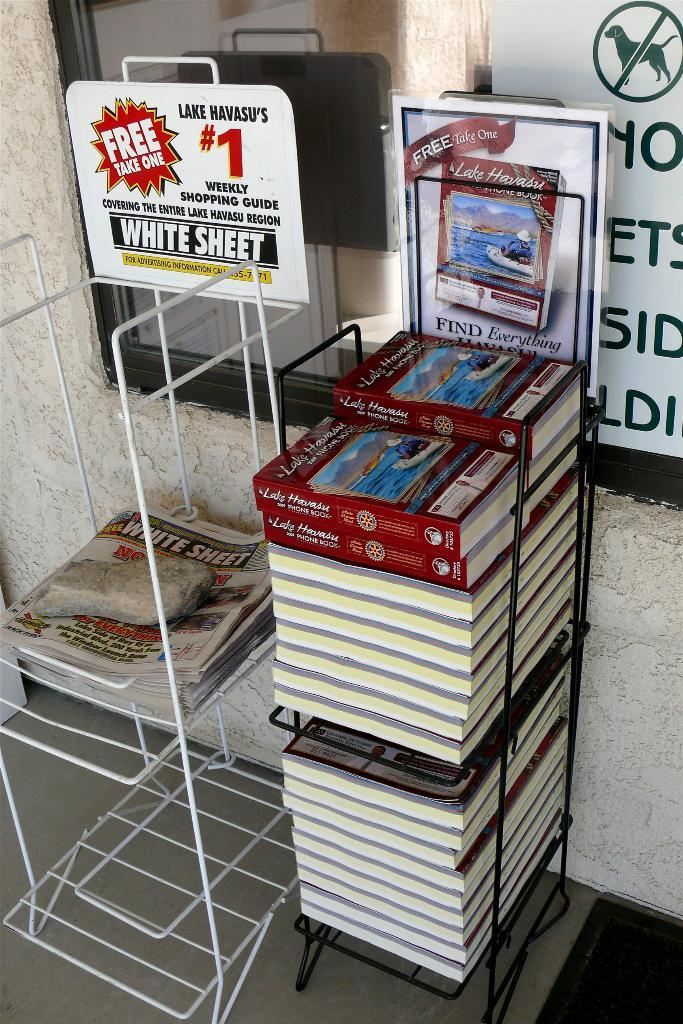<image>
Present a compact description of the photo's key features. Stands for shopping guides and phone books for Lake Havasu. 